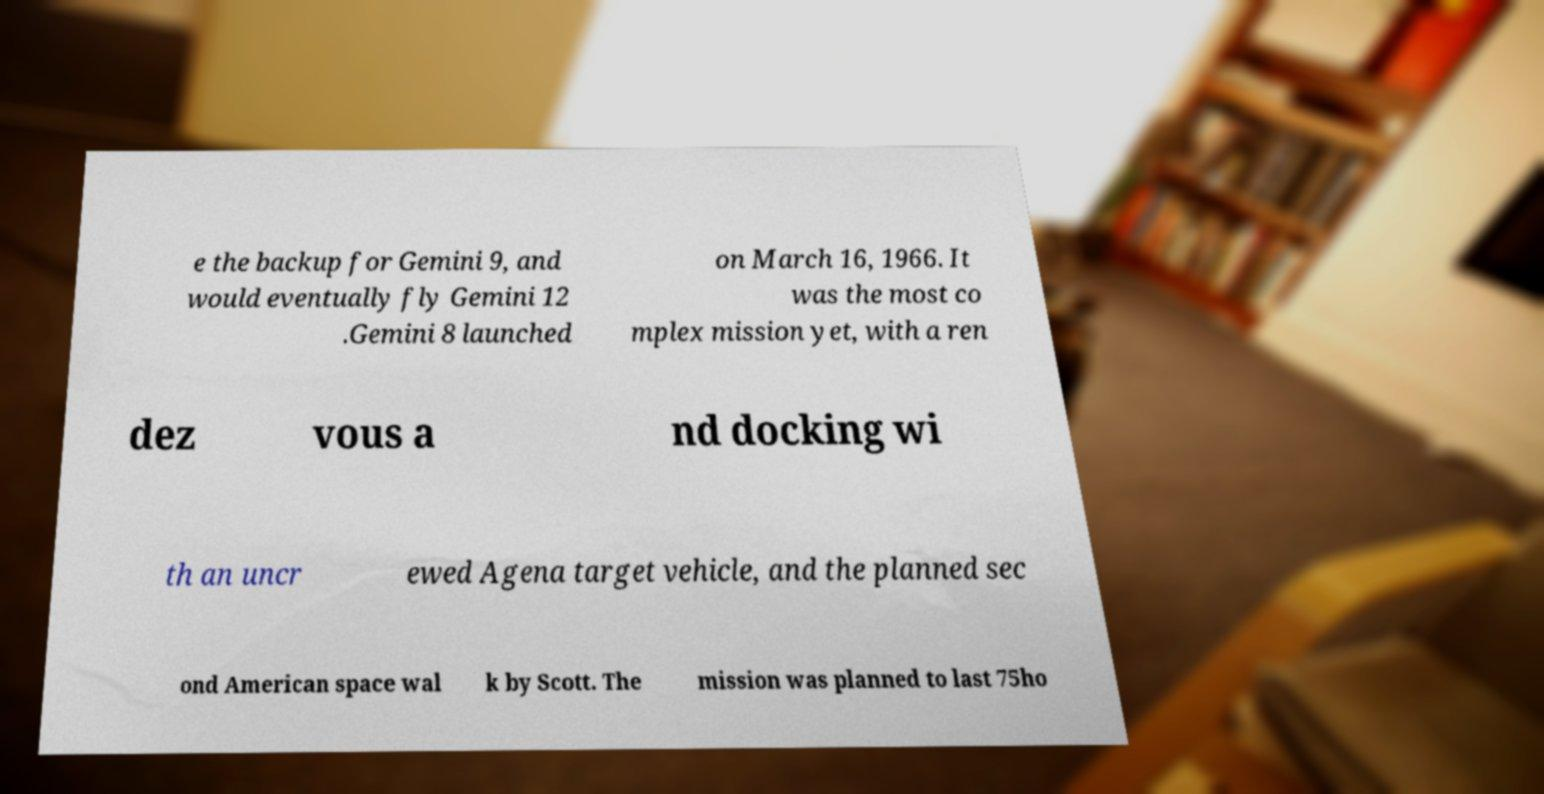What messages or text are displayed in this image? I need them in a readable, typed format. e the backup for Gemini 9, and would eventually fly Gemini 12 .Gemini 8 launched on March 16, 1966. It was the most co mplex mission yet, with a ren dez vous a nd docking wi th an uncr ewed Agena target vehicle, and the planned sec ond American space wal k by Scott. The mission was planned to last 75ho 